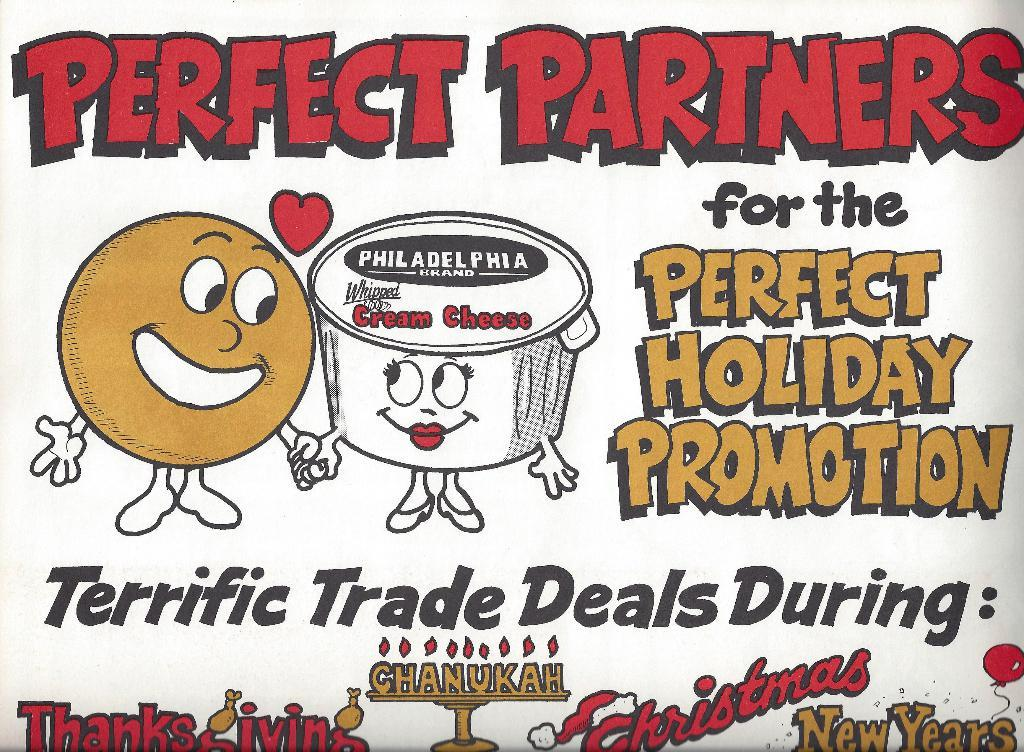What type of image is being described? The image is a poster. What can be found on the poster? There is text on the poster. Can you see any coastlines or potatoes in the poster? No, there are no coastlines or potatoes depicted in the poster; it only contains text. Is there any butter visible on the poster? No, there is not any butter present on the poster; it only contains text. 